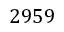<formula> <loc_0><loc_0><loc_500><loc_500>2 9 5 9</formula> 